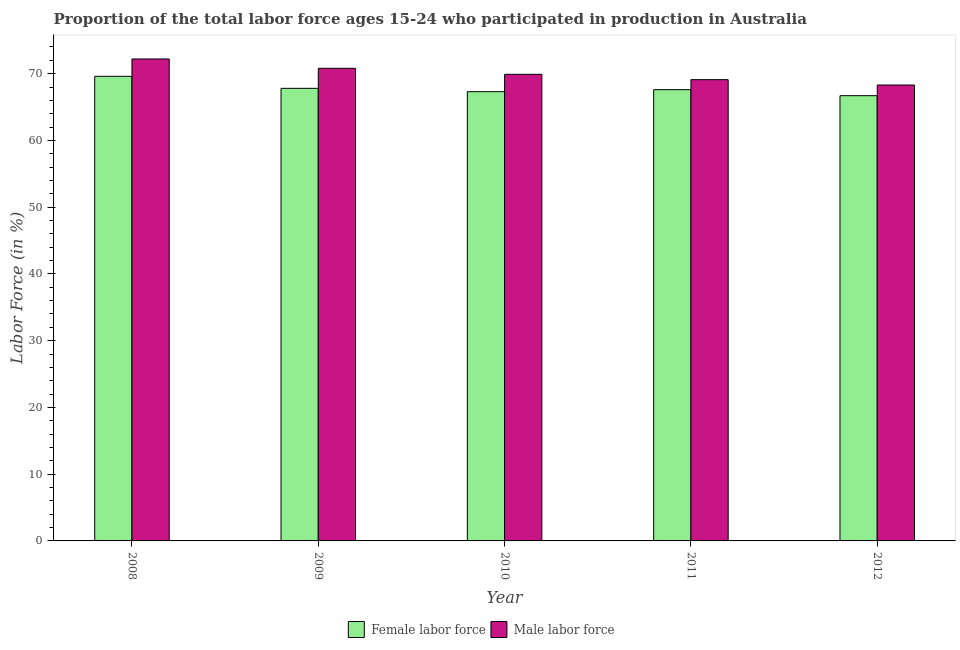How many groups of bars are there?
Keep it short and to the point. 5. Are the number of bars per tick equal to the number of legend labels?
Your response must be concise. Yes. What is the label of the 2nd group of bars from the left?
Your answer should be very brief. 2009. In how many cases, is the number of bars for a given year not equal to the number of legend labels?
Your response must be concise. 0. What is the percentage of female labor force in 2011?
Keep it short and to the point. 67.6. Across all years, what is the maximum percentage of female labor force?
Ensure brevity in your answer.  69.6. Across all years, what is the minimum percentage of male labour force?
Your answer should be very brief. 68.3. In which year was the percentage of female labor force minimum?
Keep it short and to the point. 2012. What is the total percentage of male labour force in the graph?
Keep it short and to the point. 350.3. What is the difference between the percentage of male labour force in 2010 and that in 2012?
Ensure brevity in your answer.  1.6. What is the average percentage of female labor force per year?
Offer a very short reply. 67.8. In the year 2011, what is the difference between the percentage of male labour force and percentage of female labor force?
Provide a succinct answer. 0. What is the ratio of the percentage of female labor force in 2008 to that in 2011?
Ensure brevity in your answer.  1.03. What is the difference between the highest and the second highest percentage of male labour force?
Provide a succinct answer. 1.4. What is the difference between the highest and the lowest percentage of male labour force?
Ensure brevity in your answer.  3.9. What does the 1st bar from the left in 2009 represents?
Your answer should be compact. Female labor force. What does the 2nd bar from the right in 2008 represents?
Offer a terse response. Female labor force. How many bars are there?
Your answer should be compact. 10. Are all the bars in the graph horizontal?
Make the answer very short. No. How many years are there in the graph?
Provide a succinct answer. 5. How many legend labels are there?
Ensure brevity in your answer.  2. How are the legend labels stacked?
Your answer should be very brief. Horizontal. What is the title of the graph?
Offer a terse response. Proportion of the total labor force ages 15-24 who participated in production in Australia. What is the Labor Force (in %) of Female labor force in 2008?
Ensure brevity in your answer.  69.6. What is the Labor Force (in %) in Male labor force in 2008?
Your answer should be compact. 72.2. What is the Labor Force (in %) of Female labor force in 2009?
Provide a short and direct response. 67.8. What is the Labor Force (in %) of Male labor force in 2009?
Ensure brevity in your answer.  70.8. What is the Labor Force (in %) in Female labor force in 2010?
Make the answer very short. 67.3. What is the Labor Force (in %) of Male labor force in 2010?
Provide a short and direct response. 69.9. What is the Labor Force (in %) of Female labor force in 2011?
Ensure brevity in your answer.  67.6. What is the Labor Force (in %) in Male labor force in 2011?
Make the answer very short. 69.1. What is the Labor Force (in %) in Female labor force in 2012?
Make the answer very short. 66.7. What is the Labor Force (in %) of Male labor force in 2012?
Your answer should be very brief. 68.3. Across all years, what is the maximum Labor Force (in %) of Female labor force?
Your response must be concise. 69.6. Across all years, what is the maximum Labor Force (in %) in Male labor force?
Offer a terse response. 72.2. Across all years, what is the minimum Labor Force (in %) of Female labor force?
Provide a succinct answer. 66.7. Across all years, what is the minimum Labor Force (in %) of Male labor force?
Provide a succinct answer. 68.3. What is the total Labor Force (in %) of Female labor force in the graph?
Your answer should be very brief. 339. What is the total Labor Force (in %) of Male labor force in the graph?
Your answer should be compact. 350.3. What is the difference between the Labor Force (in %) of Female labor force in 2008 and that in 2010?
Ensure brevity in your answer.  2.3. What is the difference between the Labor Force (in %) of Male labor force in 2008 and that in 2010?
Give a very brief answer. 2.3. What is the difference between the Labor Force (in %) of Male labor force in 2008 and that in 2011?
Keep it short and to the point. 3.1. What is the difference between the Labor Force (in %) of Female labor force in 2008 and that in 2012?
Your answer should be compact. 2.9. What is the difference between the Labor Force (in %) of Male labor force in 2008 and that in 2012?
Offer a very short reply. 3.9. What is the difference between the Labor Force (in %) of Male labor force in 2009 and that in 2010?
Give a very brief answer. 0.9. What is the difference between the Labor Force (in %) in Female labor force in 2009 and that in 2011?
Your answer should be compact. 0.2. What is the difference between the Labor Force (in %) of Female labor force in 2009 and that in 2012?
Offer a very short reply. 1.1. What is the difference between the Labor Force (in %) of Male labor force in 2010 and that in 2011?
Offer a very short reply. 0.8. What is the difference between the Labor Force (in %) in Female labor force in 2010 and that in 2012?
Your answer should be very brief. 0.6. What is the difference between the Labor Force (in %) in Female labor force in 2011 and that in 2012?
Ensure brevity in your answer.  0.9. What is the difference between the Labor Force (in %) of Male labor force in 2011 and that in 2012?
Provide a succinct answer. 0.8. What is the difference between the Labor Force (in %) of Female labor force in 2008 and the Labor Force (in %) of Male labor force in 2011?
Provide a short and direct response. 0.5. What is the difference between the Labor Force (in %) in Female labor force in 2009 and the Labor Force (in %) in Male labor force in 2010?
Your answer should be compact. -2.1. What is the difference between the Labor Force (in %) of Female labor force in 2009 and the Labor Force (in %) of Male labor force in 2012?
Make the answer very short. -0.5. What is the difference between the Labor Force (in %) of Female labor force in 2010 and the Labor Force (in %) of Male labor force in 2011?
Your answer should be compact. -1.8. What is the difference between the Labor Force (in %) of Female labor force in 2010 and the Labor Force (in %) of Male labor force in 2012?
Ensure brevity in your answer.  -1. What is the difference between the Labor Force (in %) of Female labor force in 2011 and the Labor Force (in %) of Male labor force in 2012?
Your answer should be very brief. -0.7. What is the average Labor Force (in %) of Female labor force per year?
Your answer should be compact. 67.8. What is the average Labor Force (in %) of Male labor force per year?
Offer a terse response. 70.06. In the year 2009, what is the difference between the Labor Force (in %) of Female labor force and Labor Force (in %) of Male labor force?
Ensure brevity in your answer.  -3. In the year 2010, what is the difference between the Labor Force (in %) in Female labor force and Labor Force (in %) in Male labor force?
Make the answer very short. -2.6. In the year 2011, what is the difference between the Labor Force (in %) of Female labor force and Labor Force (in %) of Male labor force?
Your answer should be compact. -1.5. What is the ratio of the Labor Force (in %) of Female labor force in 2008 to that in 2009?
Your response must be concise. 1.03. What is the ratio of the Labor Force (in %) in Male labor force in 2008 to that in 2009?
Your answer should be compact. 1.02. What is the ratio of the Labor Force (in %) in Female labor force in 2008 to that in 2010?
Provide a short and direct response. 1.03. What is the ratio of the Labor Force (in %) in Male labor force in 2008 to that in 2010?
Offer a terse response. 1.03. What is the ratio of the Labor Force (in %) in Female labor force in 2008 to that in 2011?
Offer a very short reply. 1.03. What is the ratio of the Labor Force (in %) of Male labor force in 2008 to that in 2011?
Offer a terse response. 1.04. What is the ratio of the Labor Force (in %) of Female labor force in 2008 to that in 2012?
Offer a terse response. 1.04. What is the ratio of the Labor Force (in %) in Male labor force in 2008 to that in 2012?
Your response must be concise. 1.06. What is the ratio of the Labor Force (in %) of Female labor force in 2009 to that in 2010?
Offer a very short reply. 1.01. What is the ratio of the Labor Force (in %) in Male labor force in 2009 to that in 2010?
Your response must be concise. 1.01. What is the ratio of the Labor Force (in %) in Female labor force in 2009 to that in 2011?
Your response must be concise. 1. What is the ratio of the Labor Force (in %) of Male labor force in 2009 to that in 2011?
Your answer should be very brief. 1.02. What is the ratio of the Labor Force (in %) of Female labor force in 2009 to that in 2012?
Ensure brevity in your answer.  1.02. What is the ratio of the Labor Force (in %) of Male labor force in 2009 to that in 2012?
Provide a short and direct response. 1.04. What is the ratio of the Labor Force (in %) in Female labor force in 2010 to that in 2011?
Your response must be concise. 1. What is the ratio of the Labor Force (in %) in Male labor force in 2010 to that in 2011?
Offer a terse response. 1.01. What is the ratio of the Labor Force (in %) in Male labor force in 2010 to that in 2012?
Provide a short and direct response. 1.02. What is the ratio of the Labor Force (in %) of Female labor force in 2011 to that in 2012?
Provide a succinct answer. 1.01. What is the ratio of the Labor Force (in %) in Male labor force in 2011 to that in 2012?
Your answer should be compact. 1.01. What is the difference between the highest and the second highest Labor Force (in %) in Male labor force?
Offer a terse response. 1.4. What is the difference between the highest and the lowest Labor Force (in %) in Female labor force?
Ensure brevity in your answer.  2.9. 